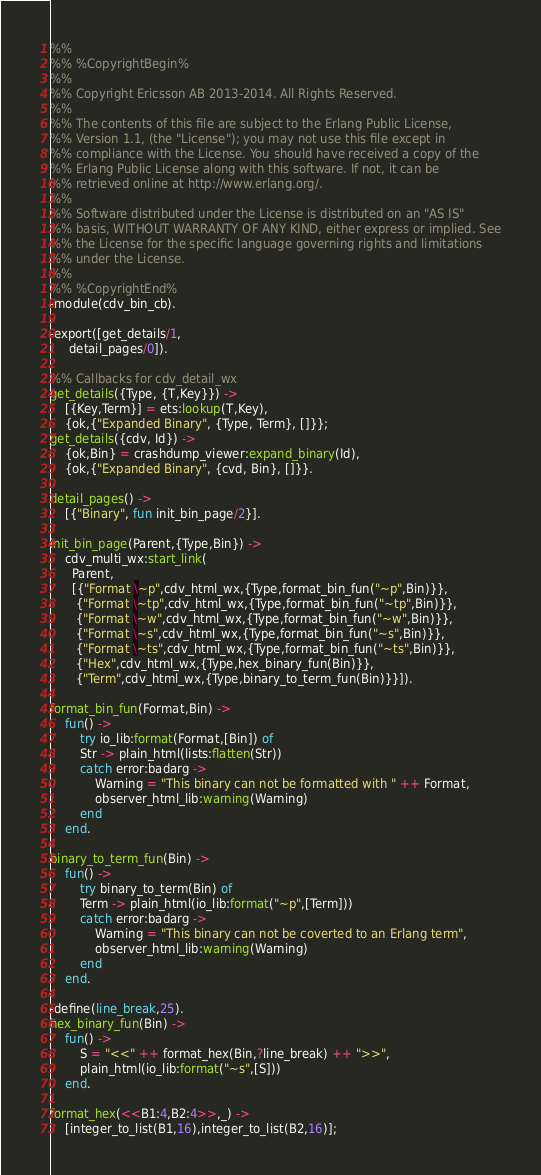<code> <loc_0><loc_0><loc_500><loc_500><_Erlang_>%%
%% %CopyrightBegin%
%%
%% Copyright Ericsson AB 2013-2014. All Rights Reserved.
%%
%% The contents of this file are subject to the Erlang Public License,
%% Version 1.1, (the "License"); you may not use this file except in
%% compliance with the License. You should have received a copy of the
%% Erlang Public License along with this software. If not, it can be
%% retrieved online at http://www.erlang.org/.
%%
%% Software distributed under the License is distributed on an "AS IS"
%% basis, WITHOUT WARRANTY OF ANY KIND, either express or implied. See
%% the License for the specific language governing rights and limitations
%% under the License.
%%
%% %CopyrightEnd%
-module(cdv_bin_cb).

-export([get_details/1,
	 detail_pages/0]).

%% Callbacks for cdv_detail_wx
get_details({Type, {T,Key}}) ->
    [{Key,Term}] = ets:lookup(T,Key),
    {ok,{"Expanded Binary", {Type, Term}, []}};
get_details({cdv, Id}) ->
    {ok,Bin} = crashdump_viewer:expand_binary(Id),
    {ok,{"Expanded Binary", {cvd, Bin}, []}}.

detail_pages() ->
    [{"Binary", fun init_bin_page/2}].

init_bin_page(Parent,{Type,Bin}) ->
    cdv_multi_wx:start_link(
      Parent,
      [{"Format \~p",cdv_html_wx,{Type,format_bin_fun("~p",Bin)}},
       {"Format \~tp",cdv_html_wx,{Type,format_bin_fun("~tp",Bin)}},
       {"Format \~w",cdv_html_wx,{Type,format_bin_fun("~w",Bin)}},
       {"Format \~s",cdv_html_wx,{Type,format_bin_fun("~s",Bin)}},
       {"Format \~ts",cdv_html_wx,{Type,format_bin_fun("~ts",Bin)}},
       {"Hex",cdv_html_wx,{Type,hex_binary_fun(Bin)}},
       {"Term",cdv_html_wx,{Type,binary_to_term_fun(Bin)}}]).

format_bin_fun(Format,Bin) ->
    fun() ->
	    try io_lib:format(Format,[Bin]) of
		Str -> plain_html(lists:flatten(Str))
	    catch error:badarg ->
		    Warning = "This binary can not be formatted with " ++ Format,
		    observer_html_lib:warning(Warning)
	    end
    end.

binary_to_term_fun(Bin) ->
    fun() ->
	    try binary_to_term(Bin) of
		Term -> plain_html(io_lib:format("~p",[Term]))
	    catch error:badarg ->
		    Warning = "This binary can not be coverted to an Erlang term",
		    observer_html_lib:warning(Warning)
	    end
    end.

-define(line_break,25).
hex_binary_fun(Bin) ->
    fun() ->
	    S = "<<" ++ format_hex(Bin,?line_break) ++ ">>",
	    plain_html(io_lib:format("~s",[S]))
    end.

format_hex(<<B1:4,B2:4>>,_) ->
    [integer_to_list(B1,16),integer_to_list(B2,16)];</code> 